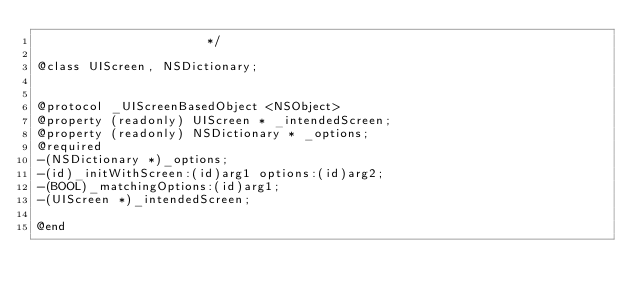Convert code to text. <code><loc_0><loc_0><loc_500><loc_500><_C_>                       */

@class UIScreen, NSDictionary;


@protocol _UIScreenBasedObject <NSObject>
@property (readonly) UIScreen * _intendedScreen; 
@property (readonly) NSDictionary * _options; 
@required
-(NSDictionary *)_options;
-(id)_initWithScreen:(id)arg1 options:(id)arg2;
-(BOOL)_matchingOptions:(id)arg1;
-(UIScreen *)_intendedScreen;

@end

</code> 